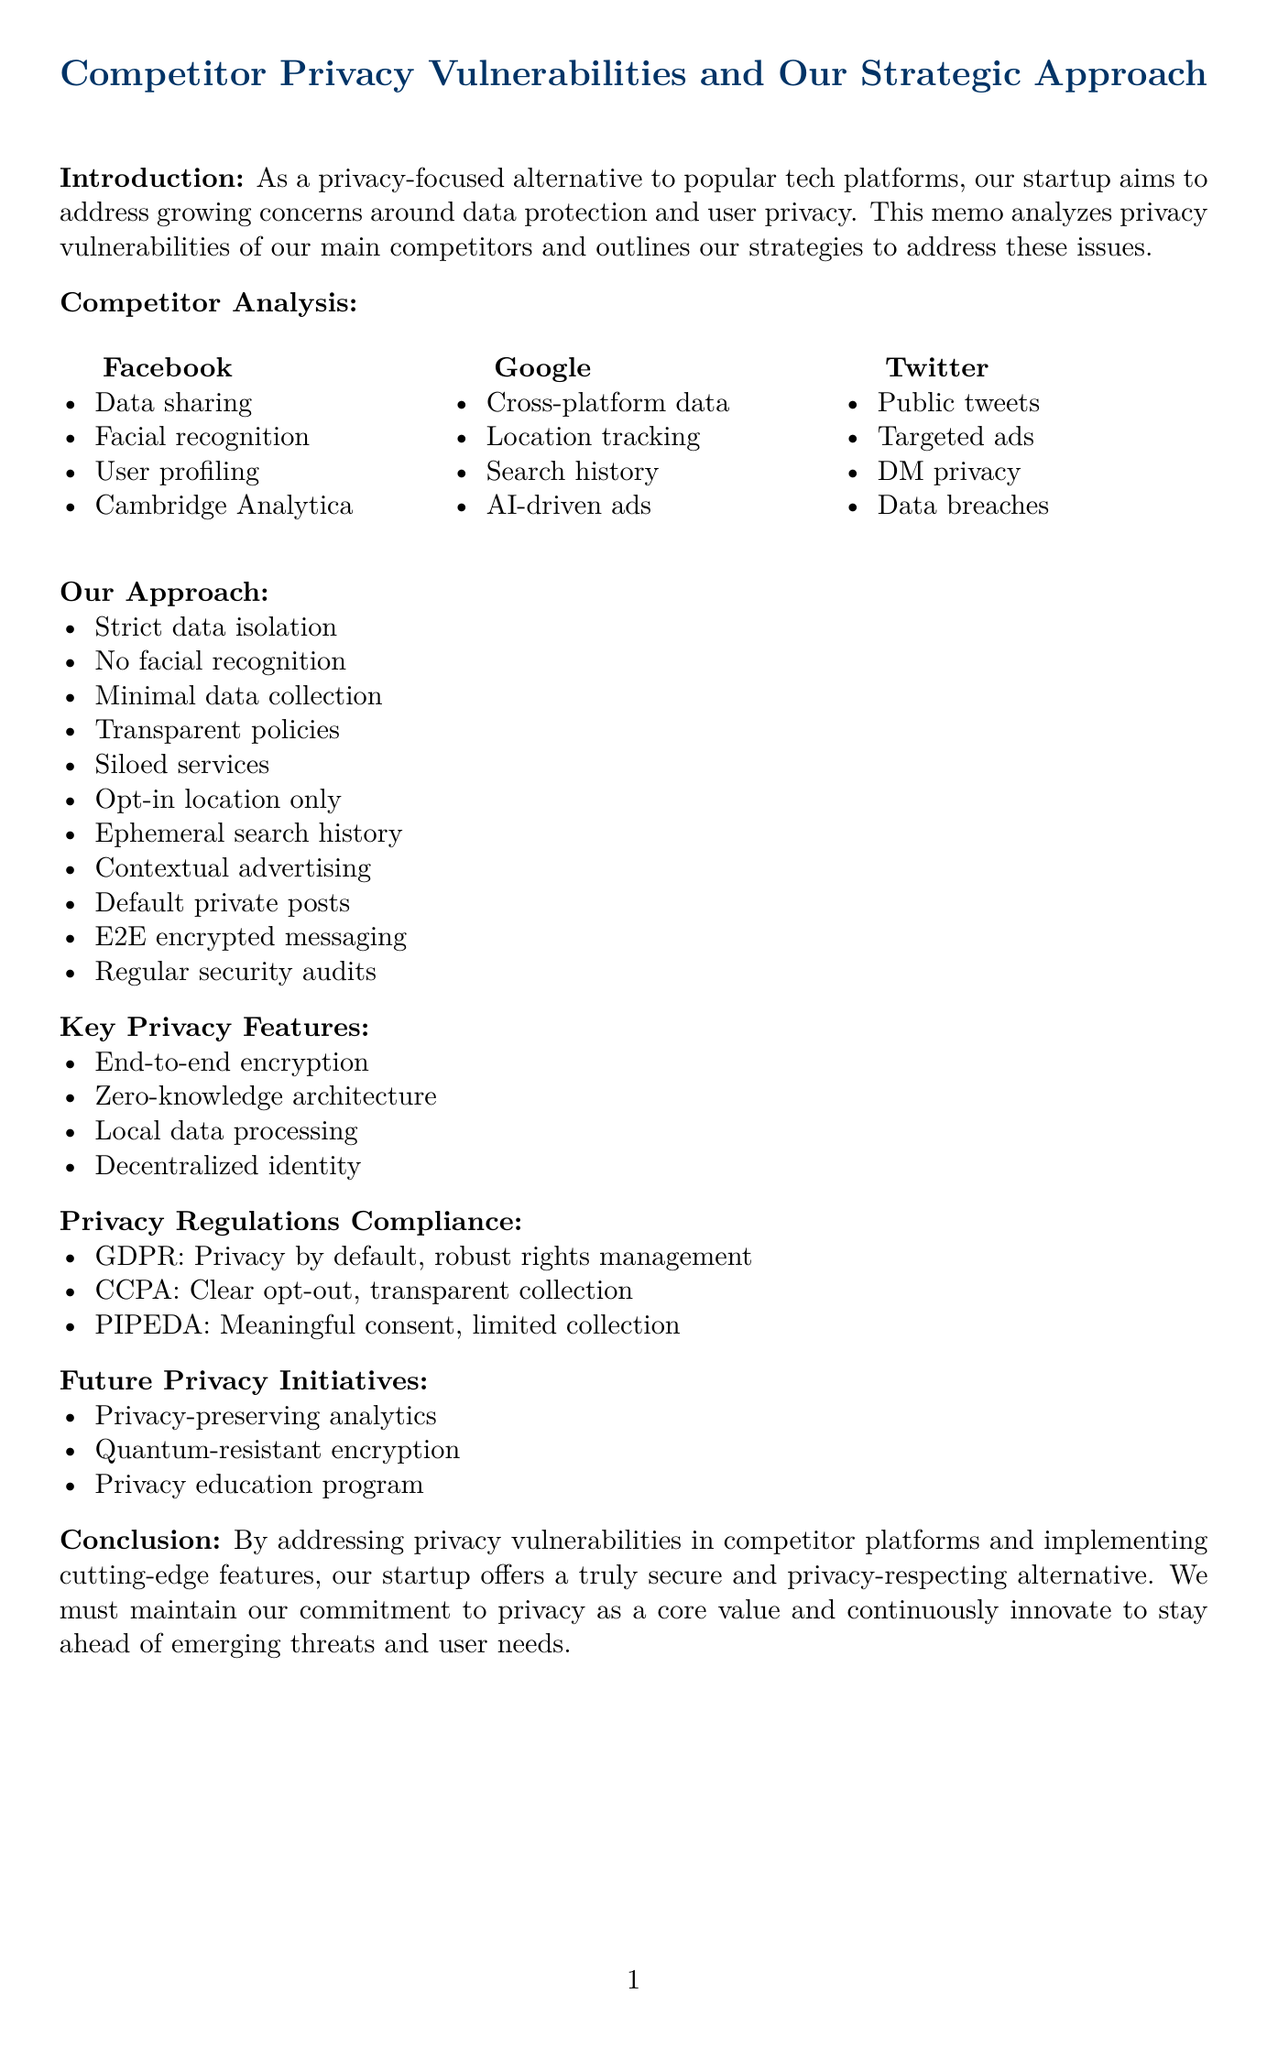what is the title of the memo? The title of the memo is explicitly stated at the beginning of the document.
Answer: Competitor Privacy Vulnerabilities and Our Strategic Approach how many companies are analyzed in the competitor analysis? The number of companies analyzed can be counted from the list provided in the competitor analysis section.
Answer: 3 which company is associated with the Cambridge Analytica scandal? Cambridge Analytica is mentioned in the vulnerabilities associated with one of the competitor companies in the document.
Answer: Facebook what is one key privacy feature mentioned in the memo? The document lists multiple privacy features, any of which can be selected as an answer.
Answer: End-to-end encryption what is our approach to comply with GDPR? The approach to comply with GDPR is clearly outlined in the privacy regulations compliance section of the document.
Answer: Privacy by default, robust rights management which future privacy initiative focuses on user education? Future privacy initiatives are listed, and one specifically mentions education.
Answer: Privacy education program how does our approach to location tracking differ from Google’s? Comparing both approaches provides insight into how our strategy contrasts with Google's strategy mentioned in the document.
Answer: Opt-in location services only what is the main purpose of the memo? The purpose of the memo is summarized in the introduction section, stating the intent clearly.
Answer: Analyze privacy vulnerabilities and outline strategies what type of architecture does our product use for user data? The document mentions a specific type of architecture that ensures privacy regarding user data.
Answer: Zero-knowledge architecture 